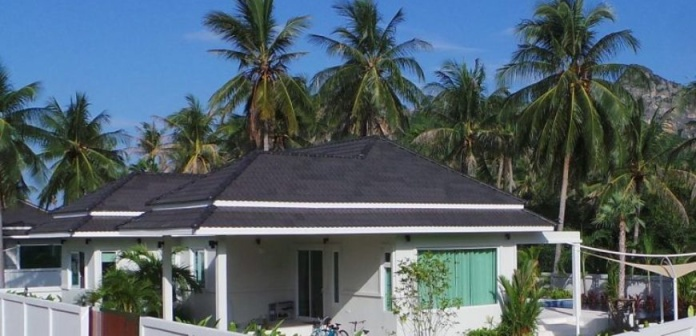What's happening in the scene? The photo depicts a tranquil tropical escape, a well-kept bungalow with a striking black roof set against the clear blue sky. The green shutters pop against the bungalow's white walls, giving it a charming, picturesque quality. In the foreground, a neatly fenced garden teases the prospect of a tranquil spot for relaxation or a casual wander. Adjacent to the fence, two bicycles stand ready, hinting at leisurely explorations or errands by the dwelling's occupants. Lush palms frame the property, betraying a light breeze, while in the distance, mist-shrouded mountains evoke a sense of mystery and adventure. The scene is a tableau of stillness, possibly in the late morning, considering the bright sunlight and clear weather, inviting thoughts of a languid day ahead filled with the simple pleasures of island life. 